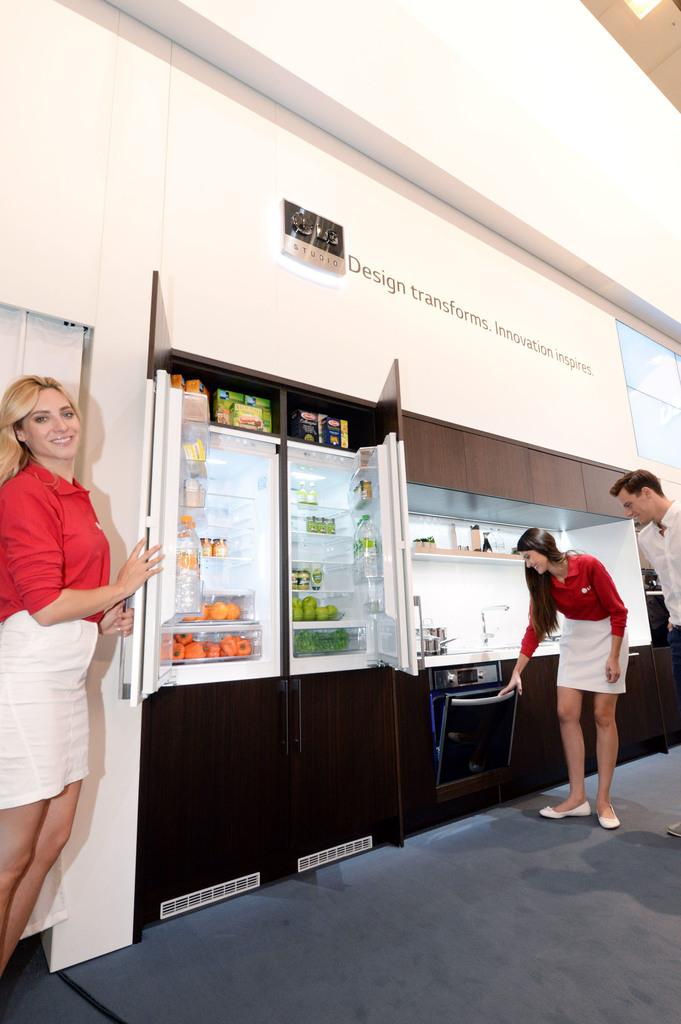Provide a one-sentence caption for the provided image. A woman stands below a wall that states, "Design transforms.". 